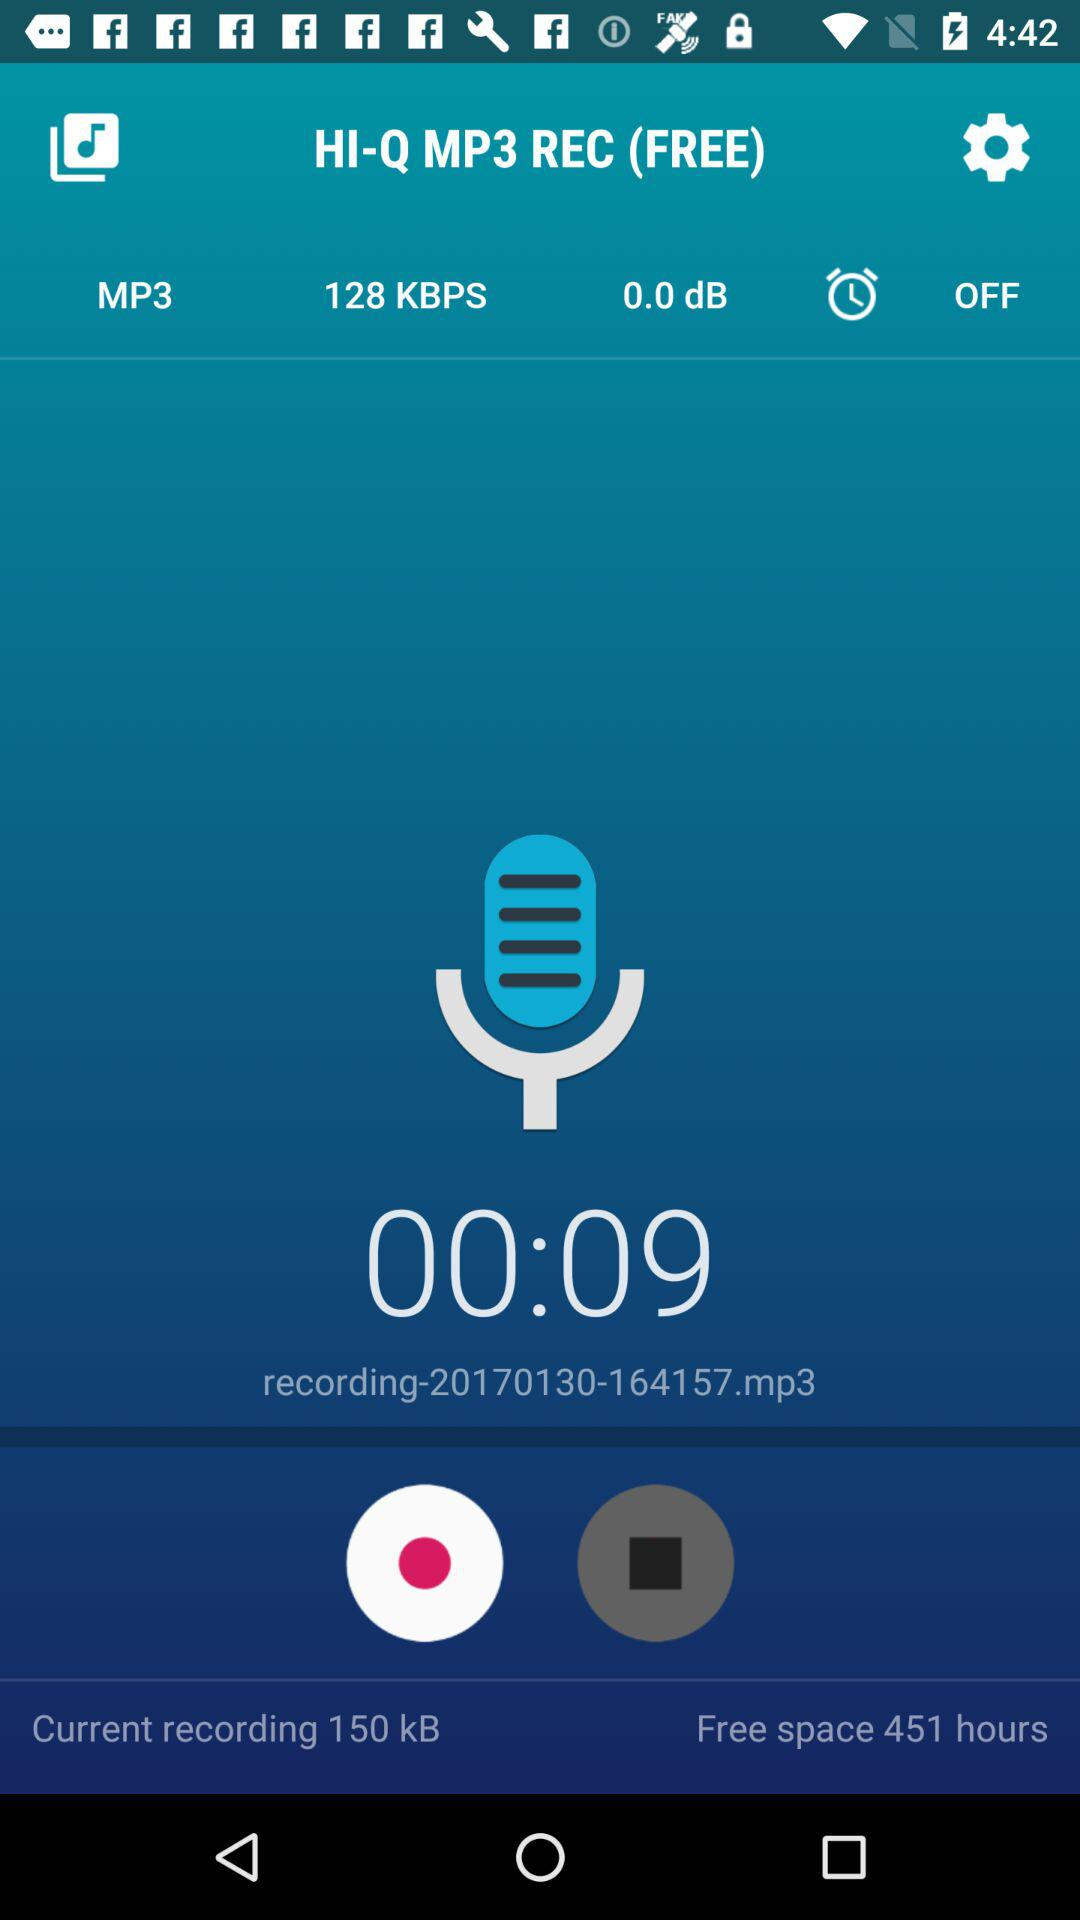What is the app name? The app name is "HI-Q MP3". 